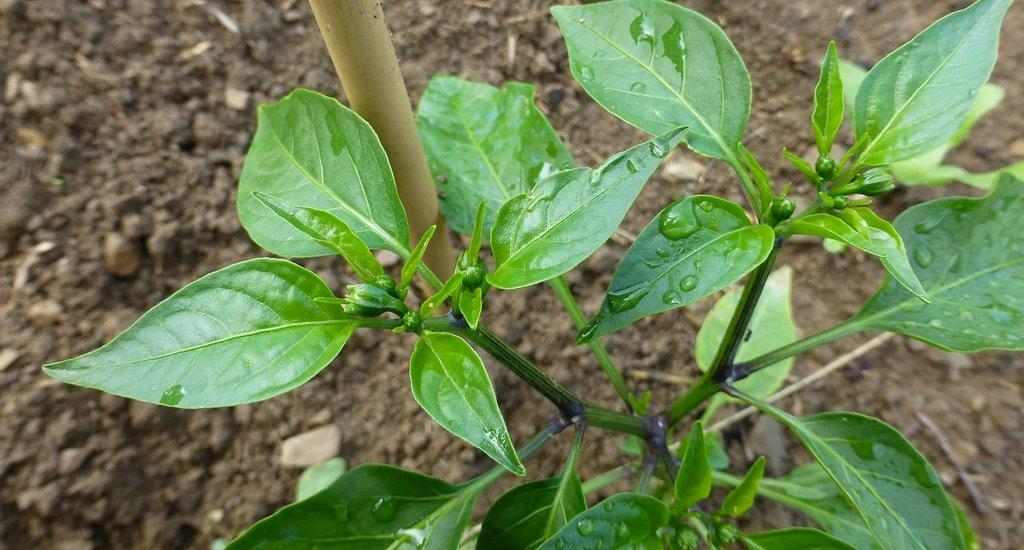What is the main subject of the image? There is a plant in the center of the image. Can you describe the plant's surroundings? There is soil visible in the background of the image. What type of flesh can be seen pulsating in the image? There is no flesh or any pulsating object present in the image; it features a plant and soil. What is the heart rate of the plant in the image? Plants do not have hearts or heart rates, so this question cannot be answered. 